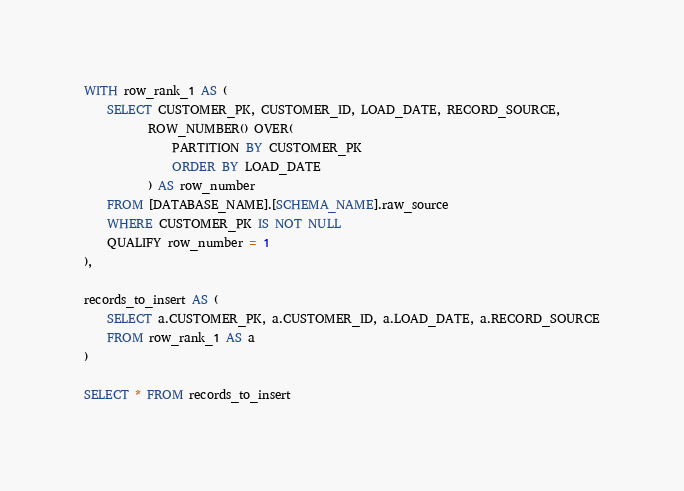Convert code to text. <code><loc_0><loc_0><loc_500><loc_500><_SQL_>WITH row_rank_1 AS (
    SELECT CUSTOMER_PK, CUSTOMER_ID, LOAD_DATE, RECORD_SOURCE,
           ROW_NUMBER() OVER(
               PARTITION BY CUSTOMER_PK
               ORDER BY LOAD_DATE
           ) AS row_number
    FROM [DATABASE_NAME].[SCHEMA_NAME].raw_source
    WHERE CUSTOMER_PK IS NOT NULL
    QUALIFY row_number = 1
),

records_to_insert AS (
    SELECT a.CUSTOMER_PK, a.CUSTOMER_ID, a.LOAD_DATE, a.RECORD_SOURCE
    FROM row_rank_1 AS a
)

SELECT * FROM records_to_insert</code> 